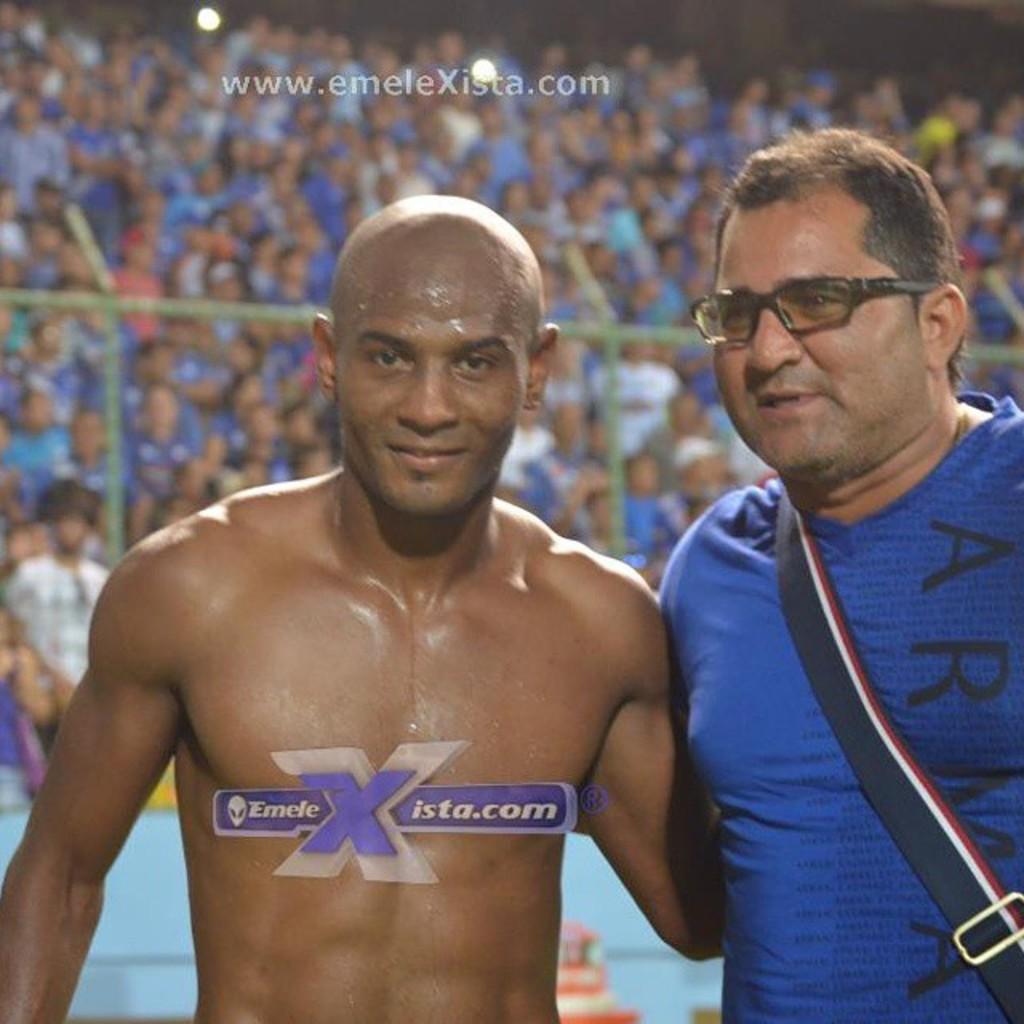<image>
Summarize the visual content of the image. An athlete poses for a picture for emeleXista.com. 